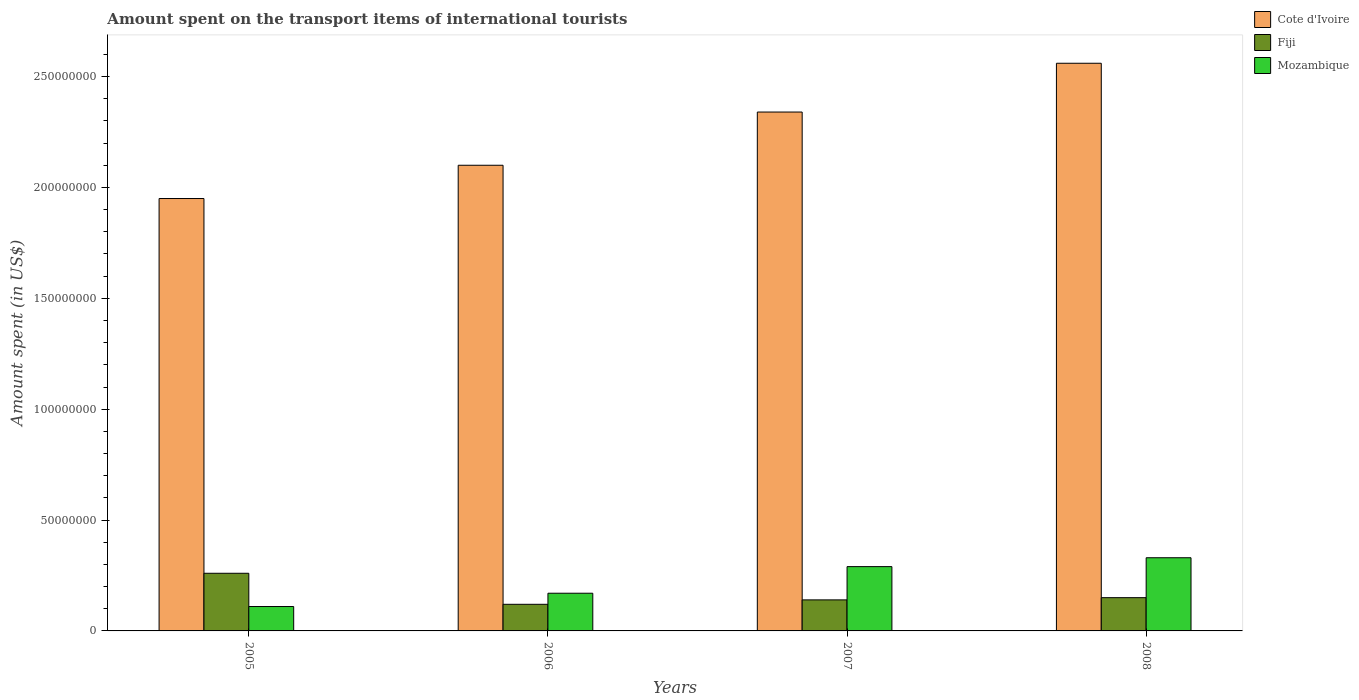Are the number of bars per tick equal to the number of legend labels?
Make the answer very short. Yes. Are the number of bars on each tick of the X-axis equal?
Ensure brevity in your answer.  Yes. How many bars are there on the 4th tick from the right?
Your response must be concise. 3. In how many cases, is the number of bars for a given year not equal to the number of legend labels?
Provide a short and direct response. 0. What is the amount spent on the transport items of international tourists in Fiji in 2007?
Offer a very short reply. 1.40e+07. Across all years, what is the maximum amount spent on the transport items of international tourists in Cote d'Ivoire?
Provide a succinct answer. 2.56e+08. Across all years, what is the minimum amount spent on the transport items of international tourists in Fiji?
Your response must be concise. 1.20e+07. In which year was the amount spent on the transport items of international tourists in Fiji maximum?
Provide a short and direct response. 2005. In which year was the amount spent on the transport items of international tourists in Fiji minimum?
Your response must be concise. 2006. What is the total amount spent on the transport items of international tourists in Cote d'Ivoire in the graph?
Provide a succinct answer. 8.95e+08. What is the difference between the amount spent on the transport items of international tourists in Cote d'Ivoire in 2006 and that in 2007?
Provide a short and direct response. -2.40e+07. What is the difference between the amount spent on the transport items of international tourists in Cote d'Ivoire in 2007 and the amount spent on the transport items of international tourists in Mozambique in 2006?
Your answer should be very brief. 2.17e+08. What is the average amount spent on the transport items of international tourists in Cote d'Ivoire per year?
Ensure brevity in your answer.  2.24e+08. In the year 2007, what is the difference between the amount spent on the transport items of international tourists in Mozambique and amount spent on the transport items of international tourists in Cote d'Ivoire?
Provide a succinct answer. -2.05e+08. In how many years, is the amount spent on the transport items of international tourists in Cote d'Ivoire greater than 150000000 US$?
Ensure brevity in your answer.  4. What is the ratio of the amount spent on the transport items of international tourists in Mozambique in 2005 to that in 2008?
Your answer should be very brief. 0.33. Is the difference between the amount spent on the transport items of international tourists in Mozambique in 2006 and 2008 greater than the difference between the amount spent on the transport items of international tourists in Cote d'Ivoire in 2006 and 2008?
Make the answer very short. Yes. What is the difference between the highest and the lowest amount spent on the transport items of international tourists in Mozambique?
Offer a very short reply. 2.20e+07. Is the sum of the amount spent on the transport items of international tourists in Fiji in 2006 and 2007 greater than the maximum amount spent on the transport items of international tourists in Mozambique across all years?
Provide a short and direct response. No. What does the 3rd bar from the left in 2007 represents?
Offer a terse response. Mozambique. What does the 3rd bar from the right in 2007 represents?
Your answer should be very brief. Cote d'Ivoire. Is it the case that in every year, the sum of the amount spent on the transport items of international tourists in Fiji and amount spent on the transport items of international tourists in Mozambique is greater than the amount spent on the transport items of international tourists in Cote d'Ivoire?
Give a very brief answer. No. How many bars are there?
Give a very brief answer. 12. Are all the bars in the graph horizontal?
Provide a succinct answer. No. What is the difference between two consecutive major ticks on the Y-axis?
Your answer should be compact. 5.00e+07. Does the graph contain any zero values?
Provide a short and direct response. No. How many legend labels are there?
Keep it short and to the point. 3. What is the title of the graph?
Offer a terse response. Amount spent on the transport items of international tourists. Does "Dominican Republic" appear as one of the legend labels in the graph?
Your response must be concise. No. What is the label or title of the X-axis?
Offer a very short reply. Years. What is the label or title of the Y-axis?
Keep it short and to the point. Amount spent (in US$). What is the Amount spent (in US$) of Cote d'Ivoire in 2005?
Offer a terse response. 1.95e+08. What is the Amount spent (in US$) of Fiji in 2005?
Provide a short and direct response. 2.60e+07. What is the Amount spent (in US$) of Mozambique in 2005?
Provide a short and direct response. 1.10e+07. What is the Amount spent (in US$) in Cote d'Ivoire in 2006?
Keep it short and to the point. 2.10e+08. What is the Amount spent (in US$) of Mozambique in 2006?
Offer a very short reply. 1.70e+07. What is the Amount spent (in US$) in Cote d'Ivoire in 2007?
Make the answer very short. 2.34e+08. What is the Amount spent (in US$) in Fiji in 2007?
Keep it short and to the point. 1.40e+07. What is the Amount spent (in US$) of Mozambique in 2007?
Offer a terse response. 2.90e+07. What is the Amount spent (in US$) in Cote d'Ivoire in 2008?
Your answer should be very brief. 2.56e+08. What is the Amount spent (in US$) in Fiji in 2008?
Your answer should be compact. 1.50e+07. What is the Amount spent (in US$) in Mozambique in 2008?
Your answer should be very brief. 3.30e+07. Across all years, what is the maximum Amount spent (in US$) of Cote d'Ivoire?
Your answer should be very brief. 2.56e+08. Across all years, what is the maximum Amount spent (in US$) of Fiji?
Provide a succinct answer. 2.60e+07. Across all years, what is the maximum Amount spent (in US$) in Mozambique?
Offer a terse response. 3.30e+07. Across all years, what is the minimum Amount spent (in US$) in Cote d'Ivoire?
Offer a very short reply. 1.95e+08. Across all years, what is the minimum Amount spent (in US$) of Mozambique?
Offer a very short reply. 1.10e+07. What is the total Amount spent (in US$) in Cote d'Ivoire in the graph?
Ensure brevity in your answer.  8.95e+08. What is the total Amount spent (in US$) in Fiji in the graph?
Give a very brief answer. 6.70e+07. What is the total Amount spent (in US$) of Mozambique in the graph?
Give a very brief answer. 9.00e+07. What is the difference between the Amount spent (in US$) in Cote d'Ivoire in 2005 and that in 2006?
Make the answer very short. -1.50e+07. What is the difference between the Amount spent (in US$) of Fiji in 2005 and that in 2006?
Give a very brief answer. 1.40e+07. What is the difference between the Amount spent (in US$) of Mozambique in 2005 and that in 2006?
Offer a very short reply. -6.00e+06. What is the difference between the Amount spent (in US$) in Cote d'Ivoire in 2005 and that in 2007?
Offer a terse response. -3.90e+07. What is the difference between the Amount spent (in US$) in Mozambique in 2005 and that in 2007?
Your response must be concise. -1.80e+07. What is the difference between the Amount spent (in US$) of Cote d'Ivoire in 2005 and that in 2008?
Your response must be concise. -6.10e+07. What is the difference between the Amount spent (in US$) in Fiji in 2005 and that in 2008?
Make the answer very short. 1.10e+07. What is the difference between the Amount spent (in US$) in Mozambique in 2005 and that in 2008?
Provide a short and direct response. -2.20e+07. What is the difference between the Amount spent (in US$) of Cote d'Ivoire in 2006 and that in 2007?
Offer a terse response. -2.40e+07. What is the difference between the Amount spent (in US$) in Fiji in 2006 and that in 2007?
Provide a short and direct response. -2.00e+06. What is the difference between the Amount spent (in US$) in Mozambique in 2006 and that in 2007?
Make the answer very short. -1.20e+07. What is the difference between the Amount spent (in US$) of Cote d'Ivoire in 2006 and that in 2008?
Provide a short and direct response. -4.60e+07. What is the difference between the Amount spent (in US$) in Mozambique in 2006 and that in 2008?
Provide a succinct answer. -1.60e+07. What is the difference between the Amount spent (in US$) of Cote d'Ivoire in 2007 and that in 2008?
Your response must be concise. -2.20e+07. What is the difference between the Amount spent (in US$) in Mozambique in 2007 and that in 2008?
Keep it short and to the point. -4.00e+06. What is the difference between the Amount spent (in US$) of Cote d'Ivoire in 2005 and the Amount spent (in US$) of Fiji in 2006?
Provide a succinct answer. 1.83e+08. What is the difference between the Amount spent (in US$) of Cote d'Ivoire in 2005 and the Amount spent (in US$) of Mozambique in 2006?
Make the answer very short. 1.78e+08. What is the difference between the Amount spent (in US$) in Fiji in 2005 and the Amount spent (in US$) in Mozambique in 2006?
Give a very brief answer. 9.00e+06. What is the difference between the Amount spent (in US$) of Cote d'Ivoire in 2005 and the Amount spent (in US$) of Fiji in 2007?
Provide a succinct answer. 1.81e+08. What is the difference between the Amount spent (in US$) of Cote d'Ivoire in 2005 and the Amount spent (in US$) of Mozambique in 2007?
Give a very brief answer. 1.66e+08. What is the difference between the Amount spent (in US$) of Fiji in 2005 and the Amount spent (in US$) of Mozambique in 2007?
Give a very brief answer. -3.00e+06. What is the difference between the Amount spent (in US$) in Cote d'Ivoire in 2005 and the Amount spent (in US$) in Fiji in 2008?
Provide a short and direct response. 1.80e+08. What is the difference between the Amount spent (in US$) of Cote d'Ivoire in 2005 and the Amount spent (in US$) of Mozambique in 2008?
Your answer should be compact. 1.62e+08. What is the difference between the Amount spent (in US$) in Fiji in 2005 and the Amount spent (in US$) in Mozambique in 2008?
Your answer should be compact. -7.00e+06. What is the difference between the Amount spent (in US$) of Cote d'Ivoire in 2006 and the Amount spent (in US$) of Fiji in 2007?
Offer a terse response. 1.96e+08. What is the difference between the Amount spent (in US$) in Cote d'Ivoire in 2006 and the Amount spent (in US$) in Mozambique in 2007?
Provide a succinct answer. 1.81e+08. What is the difference between the Amount spent (in US$) in Fiji in 2006 and the Amount spent (in US$) in Mozambique in 2007?
Give a very brief answer. -1.70e+07. What is the difference between the Amount spent (in US$) in Cote d'Ivoire in 2006 and the Amount spent (in US$) in Fiji in 2008?
Your response must be concise. 1.95e+08. What is the difference between the Amount spent (in US$) of Cote d'Ivoire in 2006 and the Amount spent (in US$) of Mozambique in 2008?
Your answer should be very brief. 1.77e+08. What is the difference between the Amount spent (in US$) of Fiji in 2006 and the Amount spent (in US$) of Mozambique in 2008?
Offer a terse response. -2.10e+07. What is the difference between the Amount spent (in US$) in Cote d'Ivoire in 2007 and the Amount spent (in US$) in Fiji in 2008?
Keep it short and to the point. 2.19e+08. What is the difference between the Amount spent (in US$) of Cote d'Ivoire in 2007 and the Amount spent (in US$) of Mozambique in 2008?
Keep it short and to the point. 2.01e+08. What is the difference between the Amount spent (in US$) of Fiji in 2007 and the Amount spent (in US$) of Mozambique in 2008?
Offer a very short reply. -1.90e+07. What is the average Amount spent (in US$) of Cote d'Ivoire per year?
Ensure brevity in your answer.  2.24e+08. What is the average Amount spent (in US$) of Fiji per year?
Give a very brief answer. 1.68e+07. What is the average Amount spent (in US$) of Mozambique per year?
Your response must be concise. 2.25e+07. In the year 2005, what is the difference between the Amount spent (in US$) of Cote d'Ivoire and Amount spent (in US$) of Fiji?
Offer a terse response. 1.69e+08. In the year 2005, what is the difference between the Amount spent (in US$) of Cote d'Ivoire and Amount spent (in US$) of Mozambique?
Your response must be concise. 1.84e+08. In the year 2005, what is the difference between the Amount spent (in US$) of Fiji and Amount spent (in US$) of Mozambique?
Your answer should be compact. 1.50e+07. In the year 2006, what is the difference between the Amount spent (in US$) of Cote d'Ivoire and Amount spent (in US$) of Fiji?
Your answer should be compact. 1.98e+08. In the year 2006, what is the difference between the Amount spent (in US$) of Cote d'Ivoire and Amount spent (in US$) of Mozambique?
Your response must be concise. 1.93e+08. In the year 2006, what is the difference between the Amount spent (in US$) of Fiji and Amount spent (in US$) of Mozambique?
Your answer should be very brief. -5.00e+06. In the year 2007, what is the difference between the Amount spent (in US$) in Cote d'Ivoire and Amount spent (in US$) in Fiji?
Provide a short and direct response. 2.20e+08. In the year 2007, what is the difference between the Amount spent (in US$) in Cote d'Ivoire and Amount spent (in US$) in Mozambique?
Keep it short and to the point. 2.05e+08. In the year 2007, what is the difference between the Amount spent (in US$) in Fiji and Amount spent (in US$) in Mozambique?
Offer a terse response. -1.50e+07. In the year 2008, what is the difference between the Amount spent (in US$) in Cote d'Ivoire and Amount spent (in US$) in Fiji?
Your answer should be very brief. 2.41e+08. In the year 2008, what is the difference between the Amount spent (in US$) of Cote d'Ivoire and Amount spent (in US$) of Mozambique?
Provide a succinct answer. 2.23e+08. In the year 2008, what is the difference between the Amount spent (in US$) of Fiji and Amount spent (in US$) of Mozambique?
Your response must be concise. -1.80e+07. What is the ratio of the Amount spent (in US$) in Fiji in 2005 to that in 2006?
Provide a short and direct response. 2.17. What is the ratio of the Amount spent (in US$) in Mozambique in 2005 to that in 2006?
Ensure brevity in your answer.  0.65. What is the ratio of the Amount spent (in US$) in Fiji in 2005 to that in 2007?
Offer a very short reply. 1.86. What is the ratio of the Amount spent (in US$) in Mozambique in 2005 to that in 2007?
Your response must be concise. 0.38. What is the ratio of the Amount spent (in US$) of Cote d'Ivoire in 2005 to that in 2008?
Provide a succinct answer. 0.76. What is the ratio of the Amount spent (in US$) in Fiji in 2005 to that in 2008?
Offer a very short reply. 1.73. What is the ratio of the Amount spent (in US$) in Mozambique in 2005 to that in 2008?
Keep it short and to the point. 0.33. What is the ratio of the Amount spent (in US$) of Cote d'Ivoire in 2006 to that in 2007?
Make the answer very short. 0.9. What is the ratio of the Amount spent (in US$) of Fiji in 2006 to that in 2007?
Offer a terse response. 0.86. What is the ratio of the Amount spent (in US$) in Mozambique in 2006 to that in 2007?
Give a very brief answer. 0.59. What is the ratio of the Amount spent (in US$) in Cote d'Ivoire in 2006 to that in 2008?
Make the answer very short. 0.82. What is the ratio of the Amount spent (in US$) of Fiji in 2006 to that in 2008?
Provide a short and direct response. 0.8. What is the ratio of the Amount spent (in US$) of Mozambique in 2006 to that in 2008?
Provide a short and direct response. 0.52. What is the ratio of the Amount spent (in US$) of Cote d'Ivoire in 2007 to that in 2008?
Ensure brevity in your answer.  0.91. What is the ratio of the Amount spent (in US$) in Mozambique in 2007 to that in 2008?
Make the answer very short. 0.88. What is the difference between the highest and the second highest Amount spent (in US$) in Cote d'Ivoire?
Make the answer very short. 2.20e+07. What is the difference between the highest and the second highest Amount spent (in US$) in Fiji?
Your answer should be very brief. 1.10e+07. What is the difference between the highest and the second highest Amount spent (in US$) in Mozambique?
Provide a succinct answer. 4.00e+06. What is the difference between the highest and the lowest Amount spent (in US$) of Cote d'Ivoire?
Your answer should be compact. 6.10e+07. What is the difference between the highest and the lowest Amount spent (in US$) in Fiji?
Provide a succinct answer. 1.40e+07. What is the difference between the highest and the lowest Amount spent (in US$) of Mozambique?
Your response must be concise. 2.20e+07. 